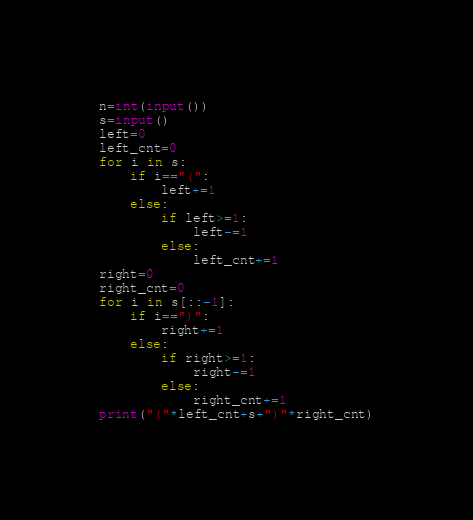Convert code to text. <code><loc_0><loc_0><loc_500><loc_500><_Python_>n=int(input())
s=input()
left=0
left_cnt=0
for i in s:
    if i=="(":
        left+=1
    else:
        if left>=1:
            left-=1
        else:
            left_cnt+=1
right=0
right_cnt=0
for i in s[::-1]:
    if i==")":
        right+=1
    else:
        if right>=1:
            right-=1
        else:
            right_cnt+=1
print("("*left_cnt+s+")"*right_cnt)</code> 